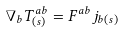<formula> <loc_0><loc_0><loc_500><loc_500>\nabla _ { b } T _ { ( s ) } ^ { a b } = F ^ { a b } j _ { b ( s ) }</formula> 